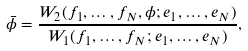<formula> <loc_0><loc_0><loc_500><loc_500>\bar { \phi } = \frac { W _ { 2 } ( f _ { 1 } , \dots , f _ { N } , \phi ; e _ { 1 } , \dots , e _ { N } ) } { W _ { 1 } ( f _ { 1 } , \dots , f _ { N } ; e _ { 1 } , \dots , e _ { N } ) } ,</formula> 